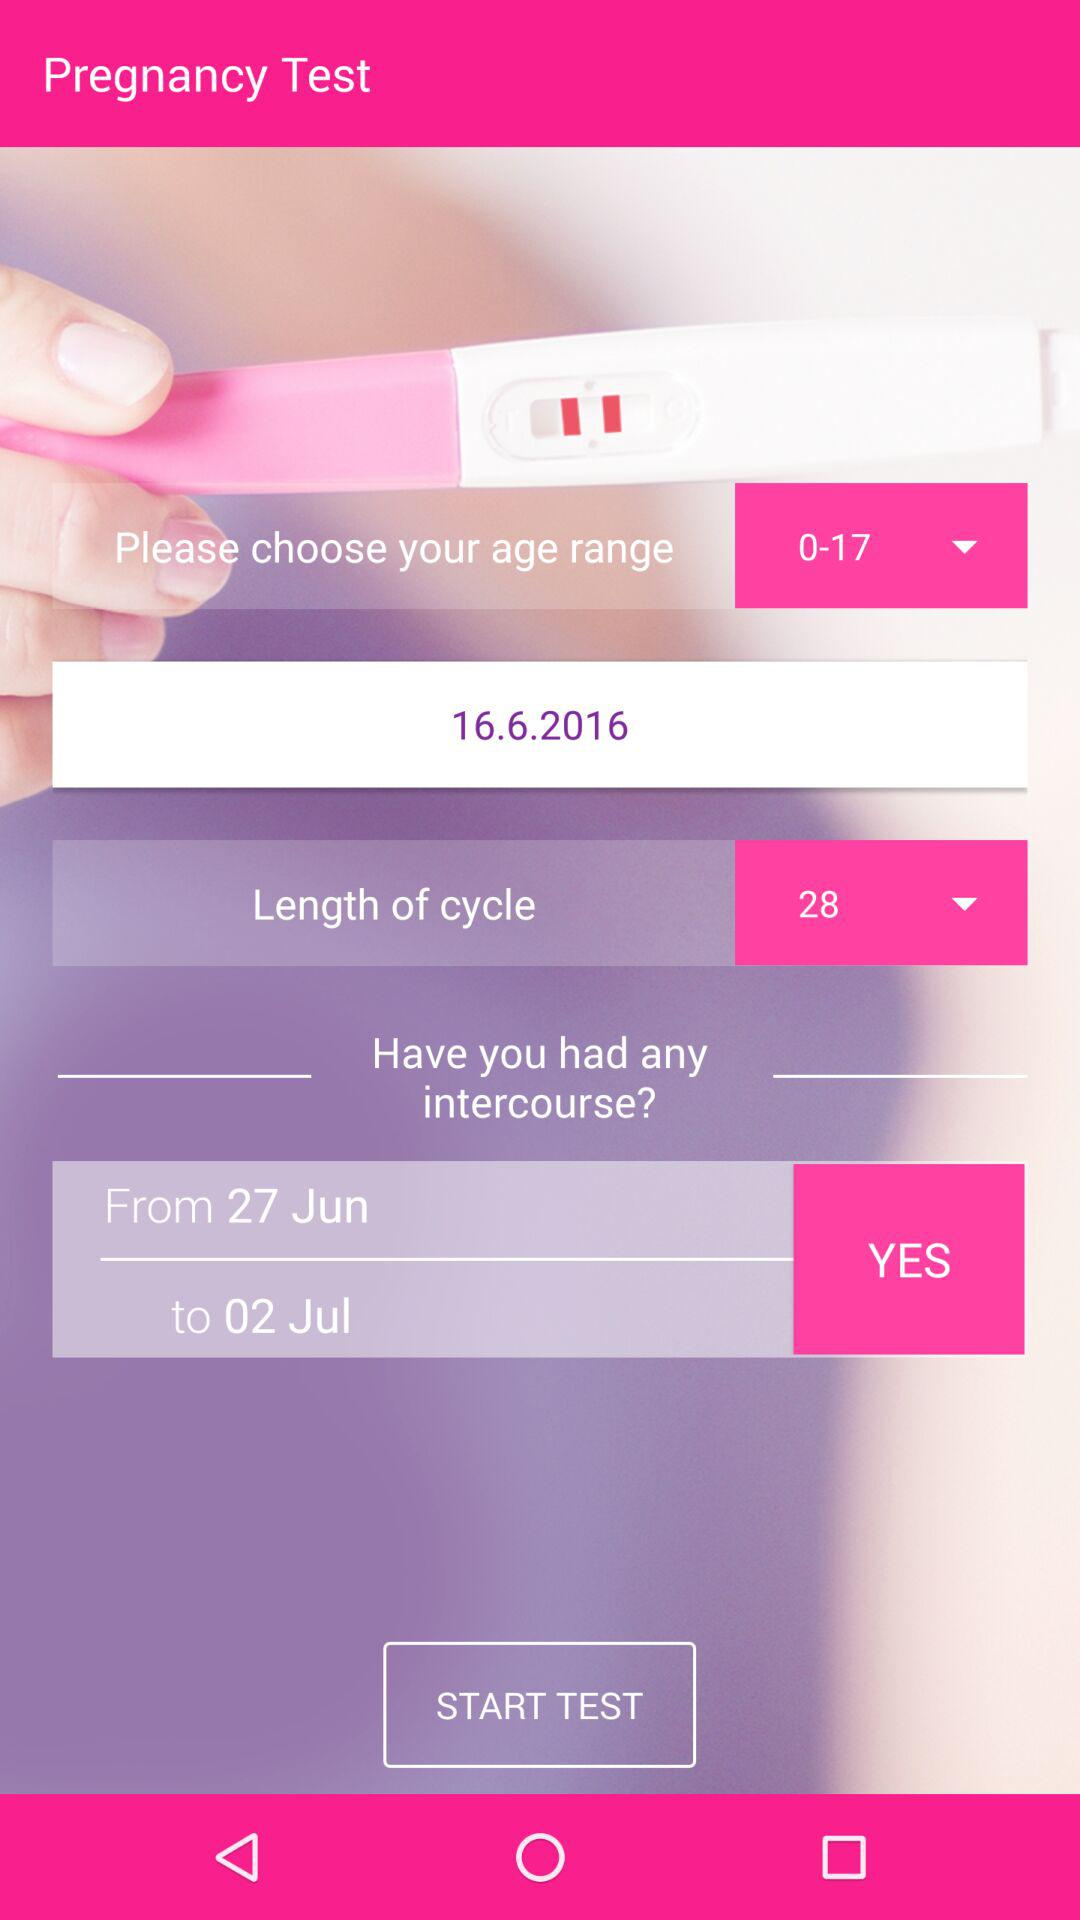What is the selected number of days for the "Length of cycle"? The selected number of days for the "Length of cycle" is 28. 